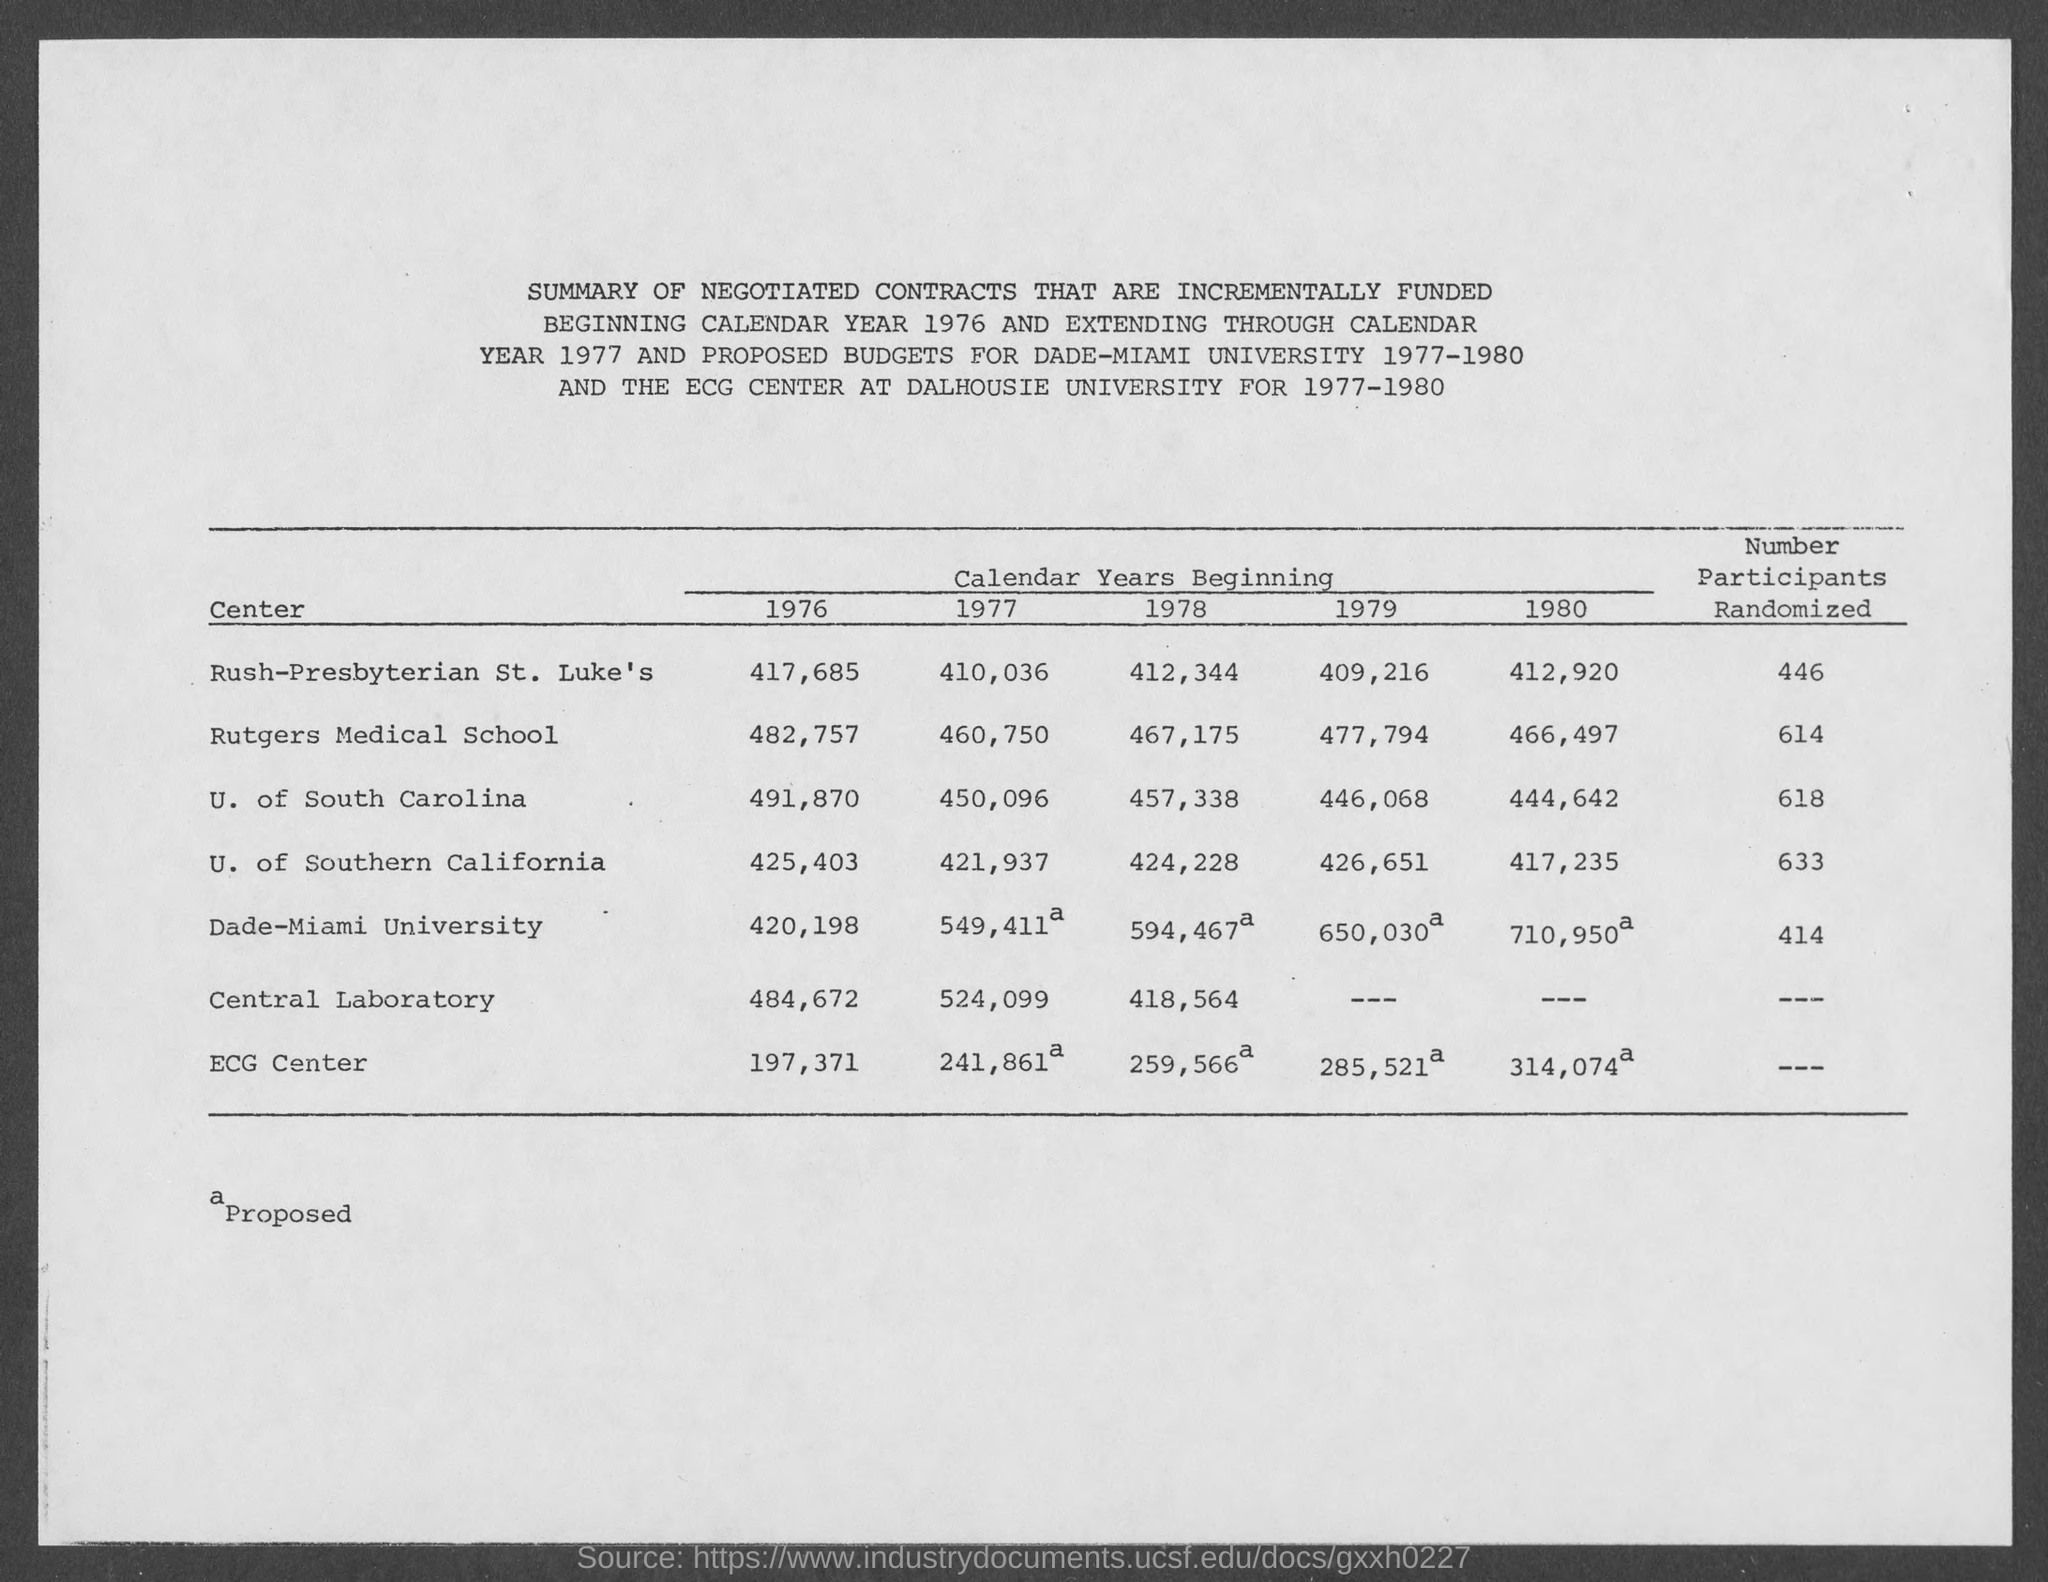Draw attention to some important aspects in this diagram. The USC center randomized 633 participants in a randomized clinical trial. The number of participants who were randomized in the Rush-Presbyterian St. Luke's Center was 446. The Rutgers Medical School center randomized 614 participants in the study. The University of South Carolina center randomized a total of 618 participants in a randomized trial. A total of 414 participants were randomly assigned to the Dade-Miami University trial. 